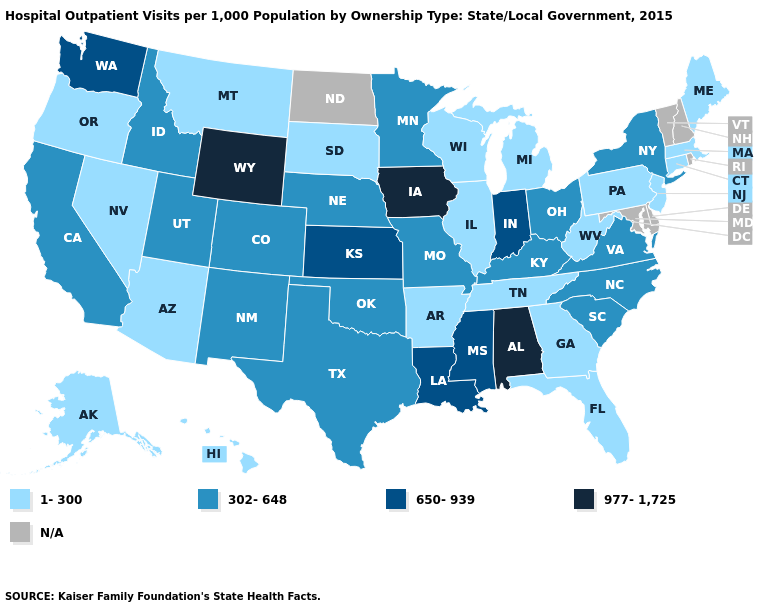Which states hav the highest value in the South?
Answer briefly. Alabama. Name the states that have a value in the range 650-939?
Keep it brief. Indiana, Kansas, Louisiana, Mississippi, Washington. Among the states that border New Mexico , does Utah have the highest value?
Concise answer only. Yes. What is the value of Hawaii?
Quick response, please. 1-300. How many symbols are there in the legend?
Write a very short answer. 5. Name the states that have a value in the range 1-300?
Quick response, please. Alaska, Arizona, Arkansas, Connecticut, Florida, Georgia, Hawaii, Illinois, Maine, Massachusetts, Michigan, Montana, Nevada, New Jersey, Oregon, Pennsylvania, South Dakota, Tennessee, West Virginia, Wisconsin. What is the highest value in states that border Nevada?
Give a very brief answer. 302-648. Name the states that have a value in the range 977-1,725?
Be succinct. Alabama, Iowa, Wyoming. What is the highest value in states that border Arkansas?
Short answer required. 650-939. Name the states that have a value in the range 650-939?
Concise answer only. Indiana, Kansas, Louisiana, Mississippi, Washington. What is the value of Vermont?
Write a very short answer. N/A. What is the value of Nebraska?
Concise answer only. 302-648. Which states have the highest value in the USA?
Answer briefly. Alabama, Iowa, Wyoming. 